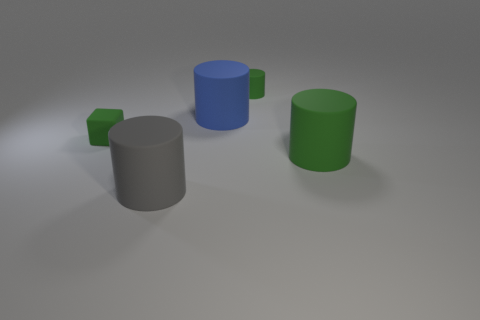Subtract all large gray rubber cylinders. How many cylinders are left? 3 Add 4 big shiny blocks. How many objects exist? 9 Subtract all blue cylinders. How many cylinders are left? 3 Subtract all cyan spheres. How many green cylinders are left? 2 Subtract 2 cylinders. How many cylinders are left? 2 Subtract all brown cylinders. Subtract all green cubes. How many cylinders are left? 4 Subtract all blue things. Subtract all small green things. How many objects are left? 2 Add 3 large things. How many large things are left? 6 Add 4 large gray cylinders. How many large gray cylinders exist? 5 Subtract 0 yellow cubes. How many objects are left? 5 